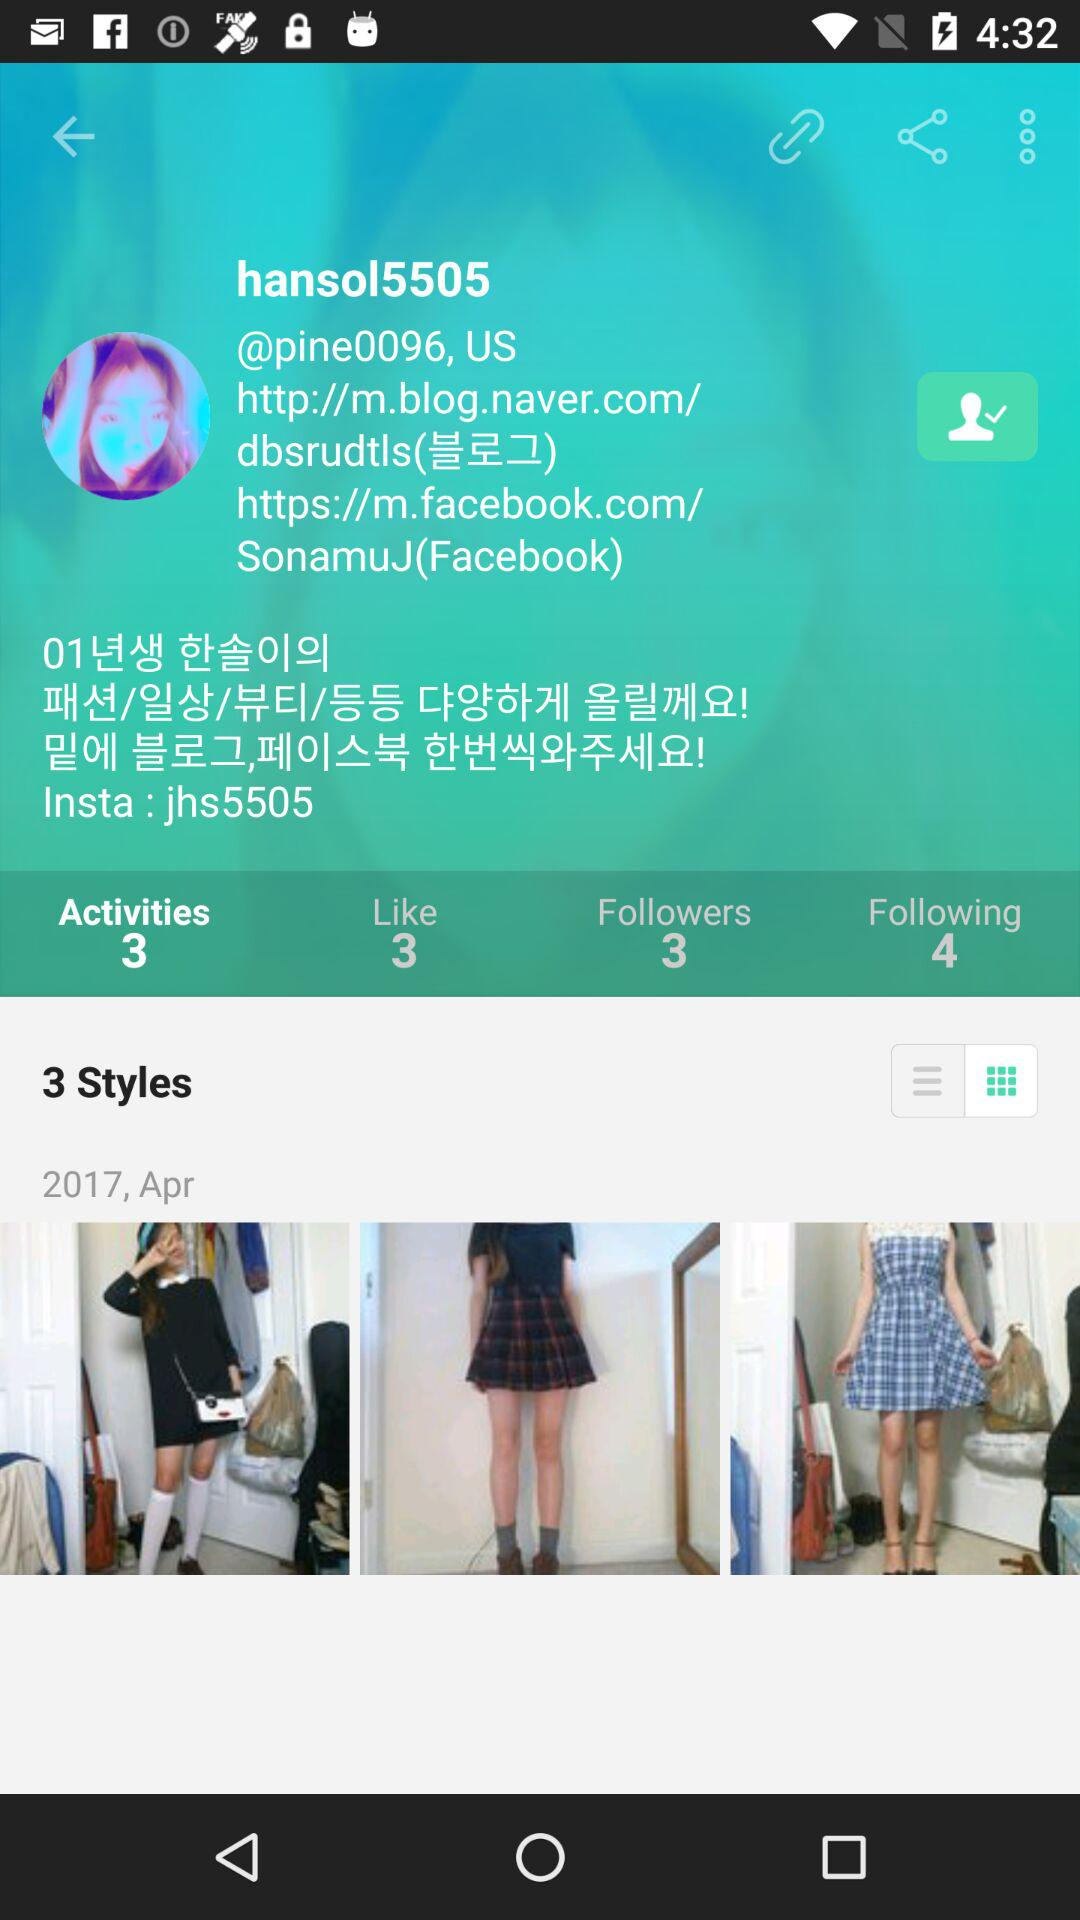What is the given year? The given year is 2017. 